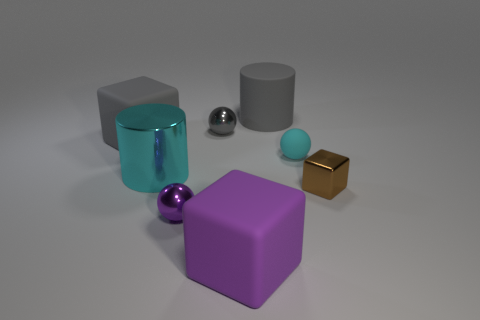What number of small balls are in front of the cyan matte thing?
Your answer should be compact. 1. Is the material of the ball in front of the tiny brown cube the same as the large gray cylinder?
Ensure brevity in your answer.  No. How many other objects are the same shape as the large cyan shiny thing?
Offer a terse response. 1. What number of big gray cubes are behind the gray thing left of the purple thing that is left of the gray sphere?
Keep it short and to the point. 0. The big block that is behind the large purple matte cube is what color?
Your answer should be very brief. Gray. There is a block that is to the left of the small gray metallic thing; is its color the same as the big rubber cylinder?
Offer a very short reply. Yes. There is a purple thing that is the same shape as the cyan matte thing; what is its size?
Offer a very short reply. Small. What material is the tiny sphere in front of the cylinder left of the tiny metallic ball in front of the small block?
Offer a terse response. Metal. Is the number of rubber things on the right side of the metallic cylinder greater than the number of cylinders that are behind the cyan sphere?
Offer a terse response. Yes. Is the gray rubber cylinder the same size as the cyan rubber ball?
Give a very brief answer. No. 